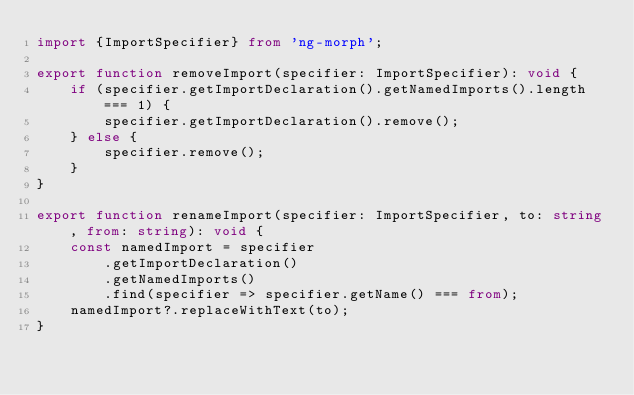<code> <loc_0><loc_0><loc_500><loc_500><_TypeScript_>import {ImportSpecifier} from 'ng-morph';

export function removeImport(specifier: ImportSpecifier): void {
    if (specifier.getImportDeclaration().getNamedImports().length === 1) {
        specifier.getImportDeclaration().remove();
    } else {
        specifier.remove();
    }
}

export function renameImport(specifier: ImportSpecifier, to: string, from: string): void {
    const namedImport = specifier
        .getImportDeclaration()
        .getNamedImports()
        .find(specifier => specifier.getName() === from);
    namedImport?.replaceWithText(to);
}
</code> 